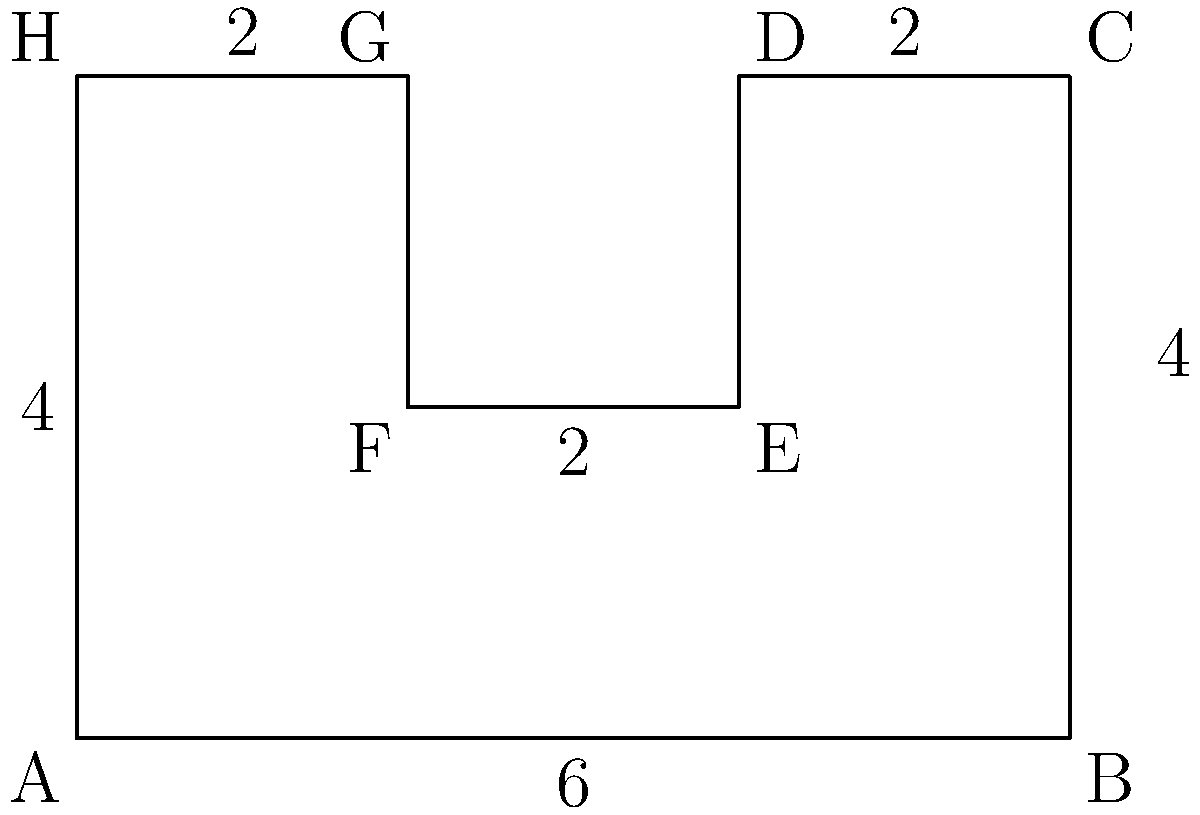As a vigilant moderator, you're tasked with calculating the perimeter of an irregular polygon representing a moderation zone in an online community platform. The zone is shaped as shown in the diagram, with measurements in arbitrary units. What is the total perimeter of this moderation zone? To calculate the perimeter of this irregular polygon, we need to sum up the lengths of all sides:

1. Side AB: $6$ units
2. Side BC: $4$ units
3. Side CD: $2$ units
4. Side DE: $2$ units (vertical)
5. Side EF: $2$ units
6. Side FG: $2$ units (vertical)
7. Side GH: $2$ units
8. Side HA: $4$ units

Now, let's sum up all these lengths:

$$ \text{Perimeter} = 6 + 4 + 2 + 2 + 2 + 2 + 2 + 4 = 24 $$

Therefore, the total perimeter of the moderation zone is 24 units.
Answer: 24 units 